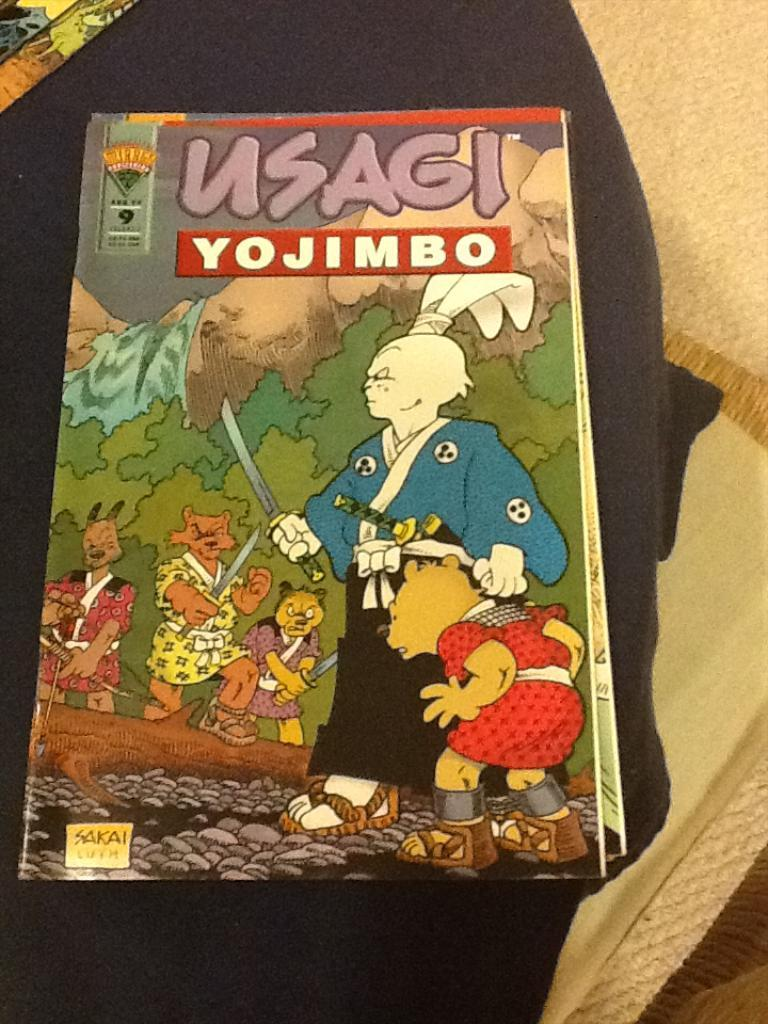<image>
Share a concise interpretation of the image provided. A Comic Book with a samurai rabbit on the front called USAGI YOJIMBO. 